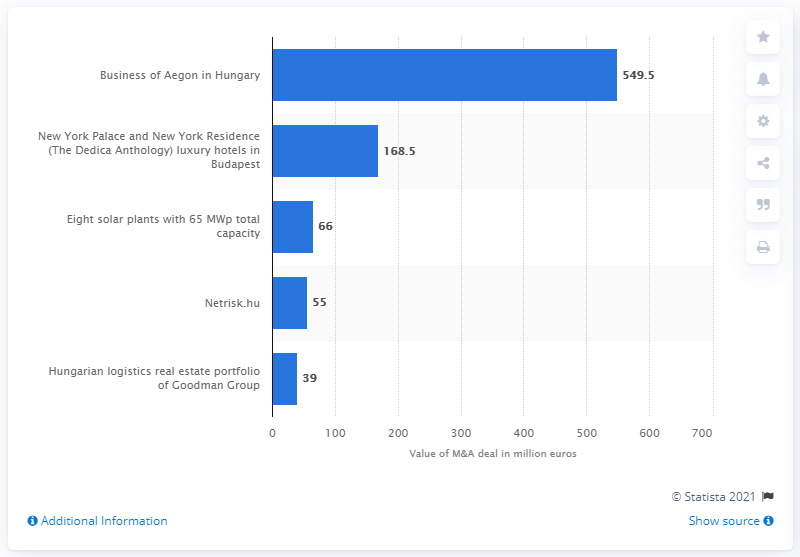Mention a couple of crucial points in this snapshot. The largest deal in Hungary in 2020 was 549.5 million. 